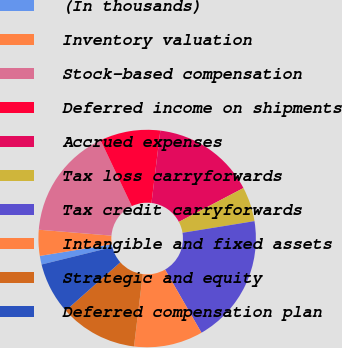Convert chart to OTSL. <chart><loc_0><loc_0><loc_500><loc_500><pie_chart><fcel>(In thousands)<fcel>Inventory valuation<fcel>Stock-based compensation<fcel>Deferred income on shipments<fcel>Accrued expenses<fcel>Tax loss carryforwards<fcel>Tax credit carryforwards<fcel>Intangible and fixed assets<fcel>Strategic and equity<fcel>Deferred compensation plan<nl><fcel>1.28%<fcel>3.85%<fcel>16.67%<fcel>8.97%<fcel>15.38%<fcel>5.13%<fcel>19.23%<fcel>10.26%<fcel>11.54%<fcel>7.69%<nl></chart> 